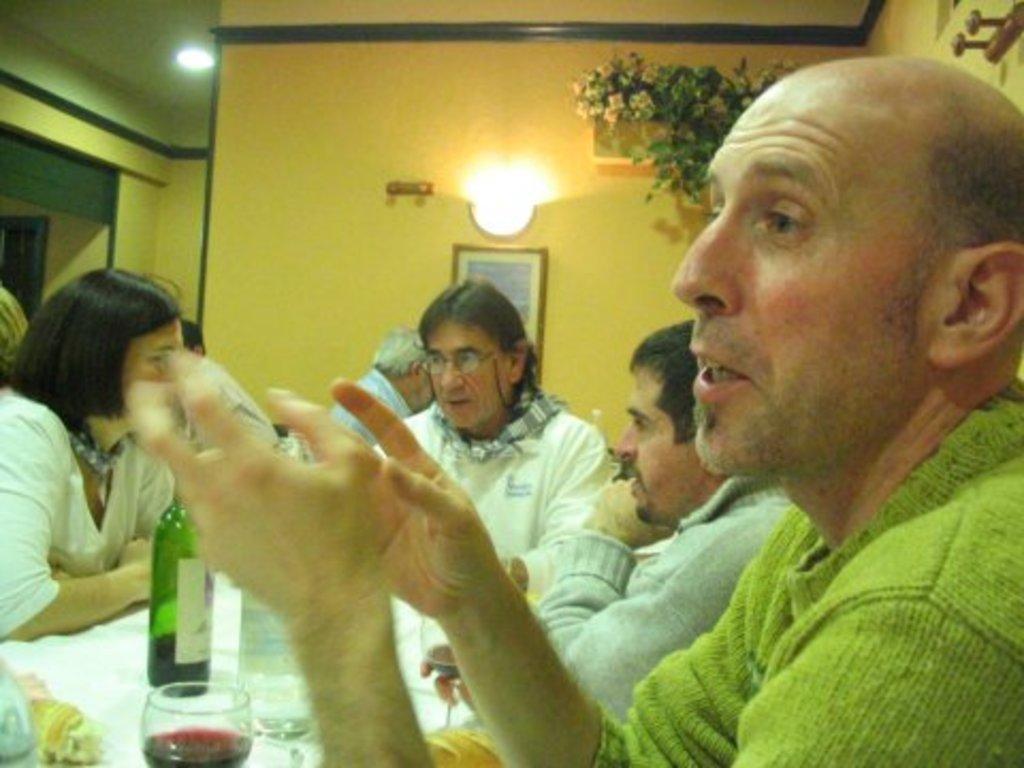How would you summarize this image in a sentence or two? In this picture we can see people sitting and talking to each other. On the table we have a glass of wine and a bottle. In the background we have lights & flowers. 